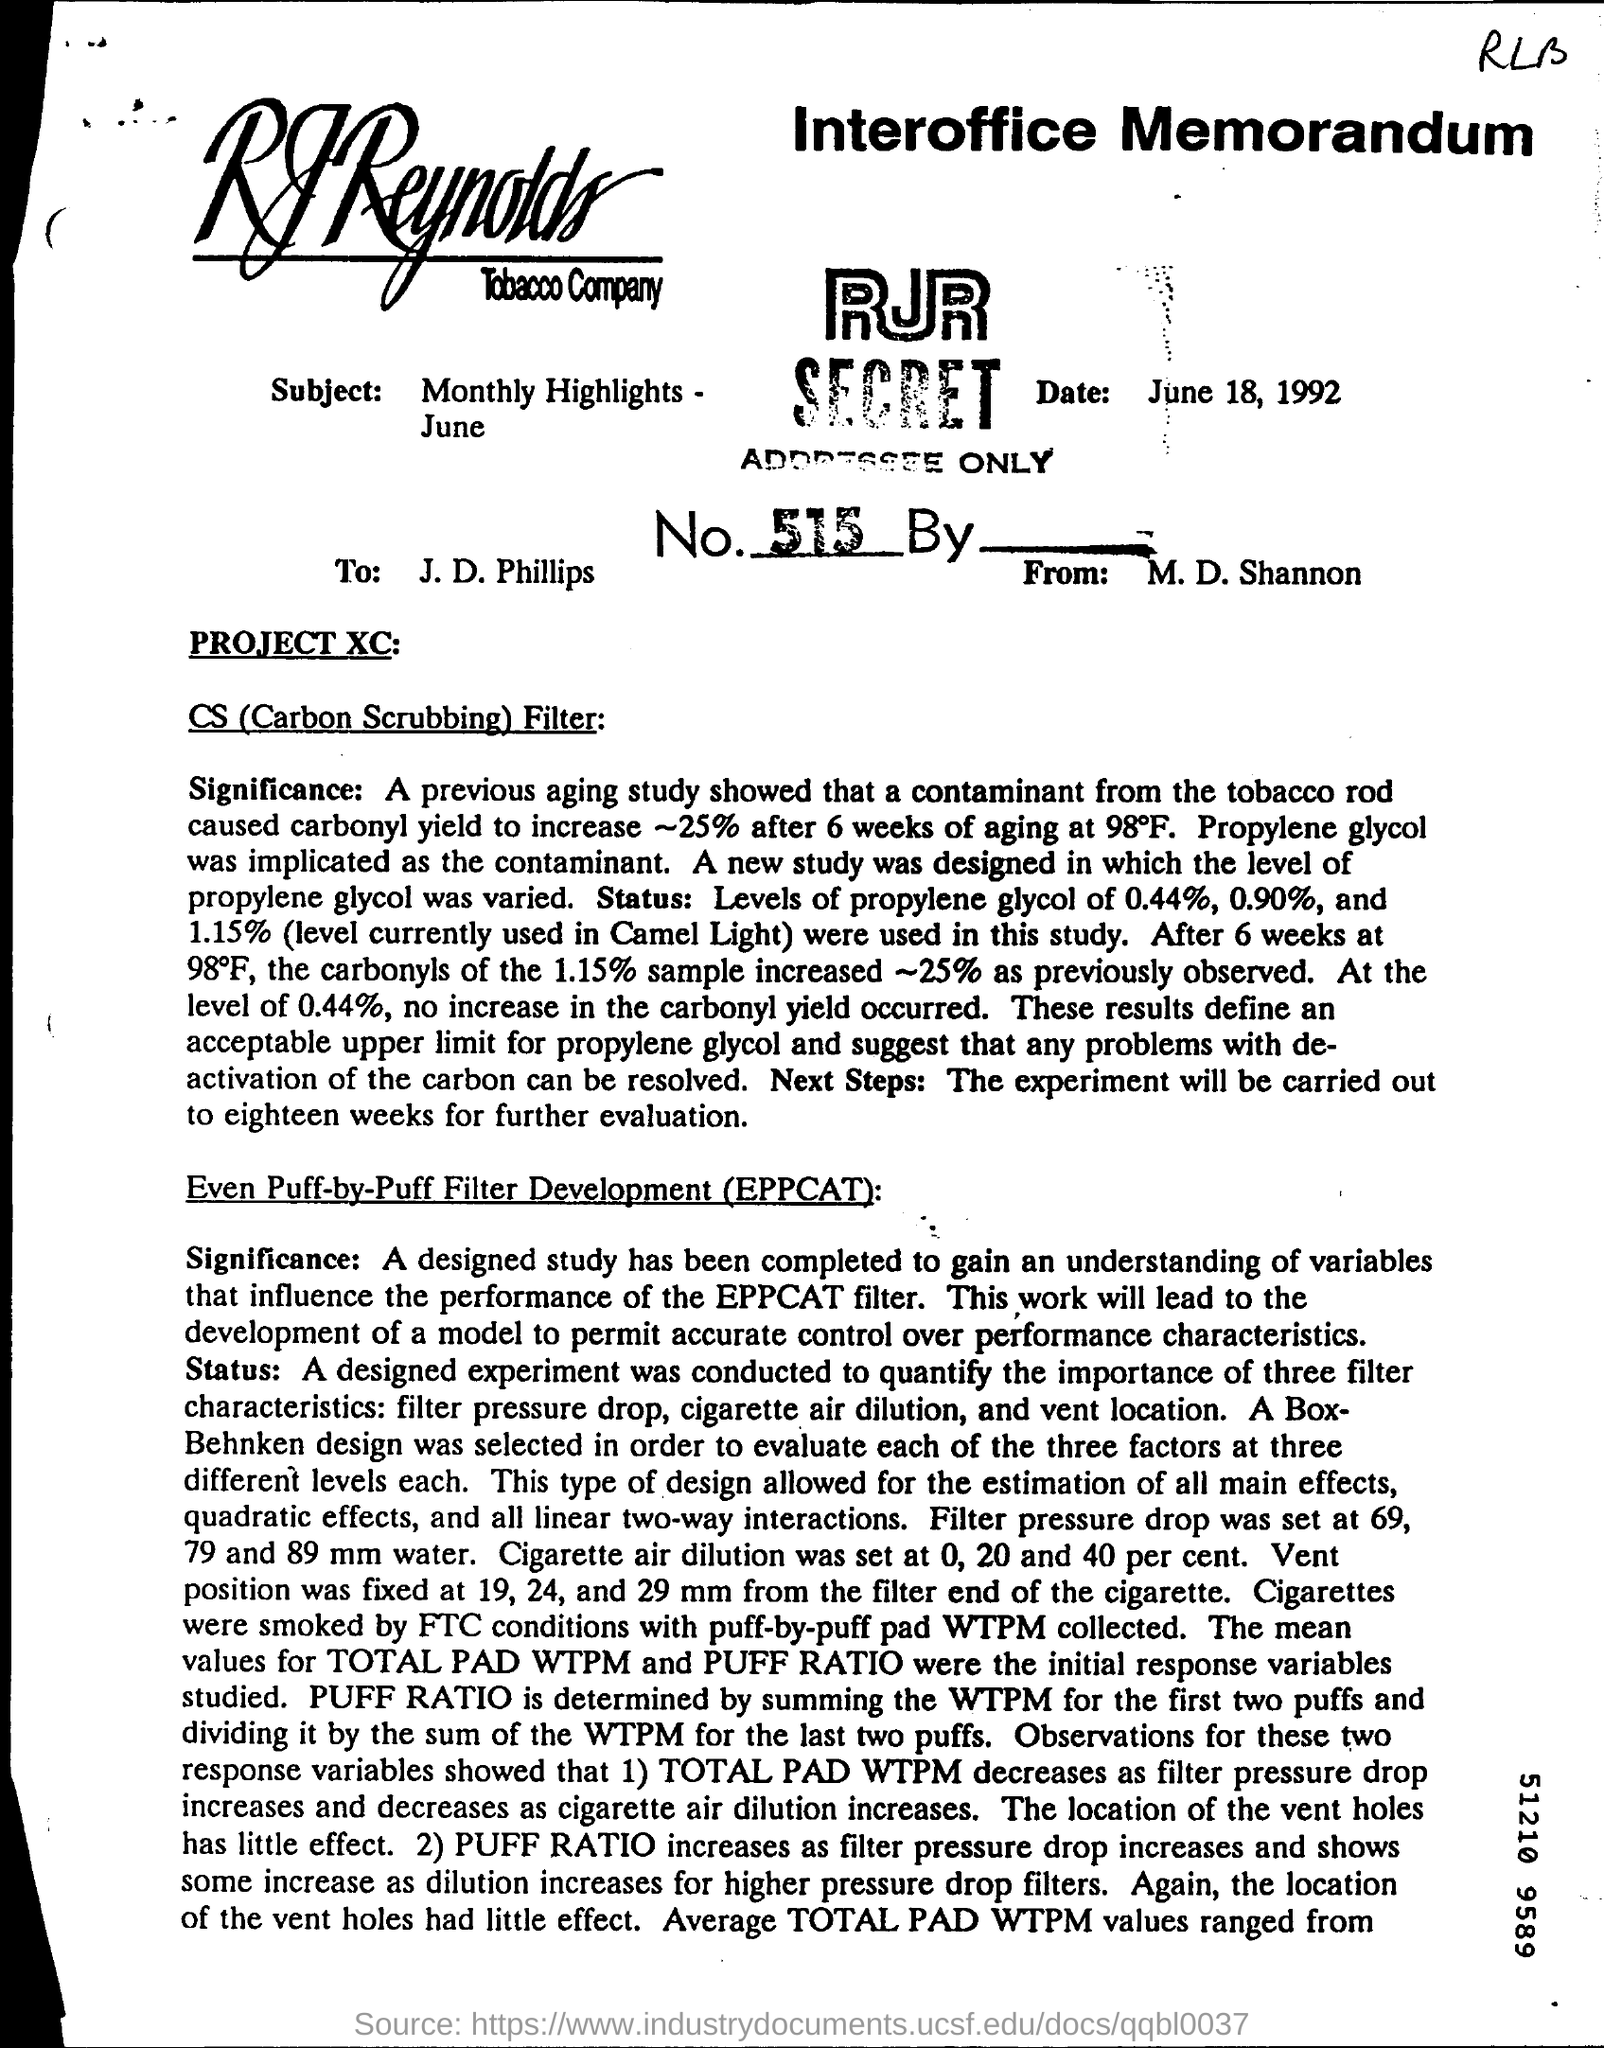What is the name of the tobacco company?
Your answer should be compact. R J Reynolds tobacco company. Who is this interoffice memorandum addressed to?
Offer a terse response. J. D. Phillips. What is the date mentioned?
Provide a short and direct response. June 18, 1992. What is the title of the second paragraph?
Make the answer very short. Even puff-by-puff filter development (eppcat). 